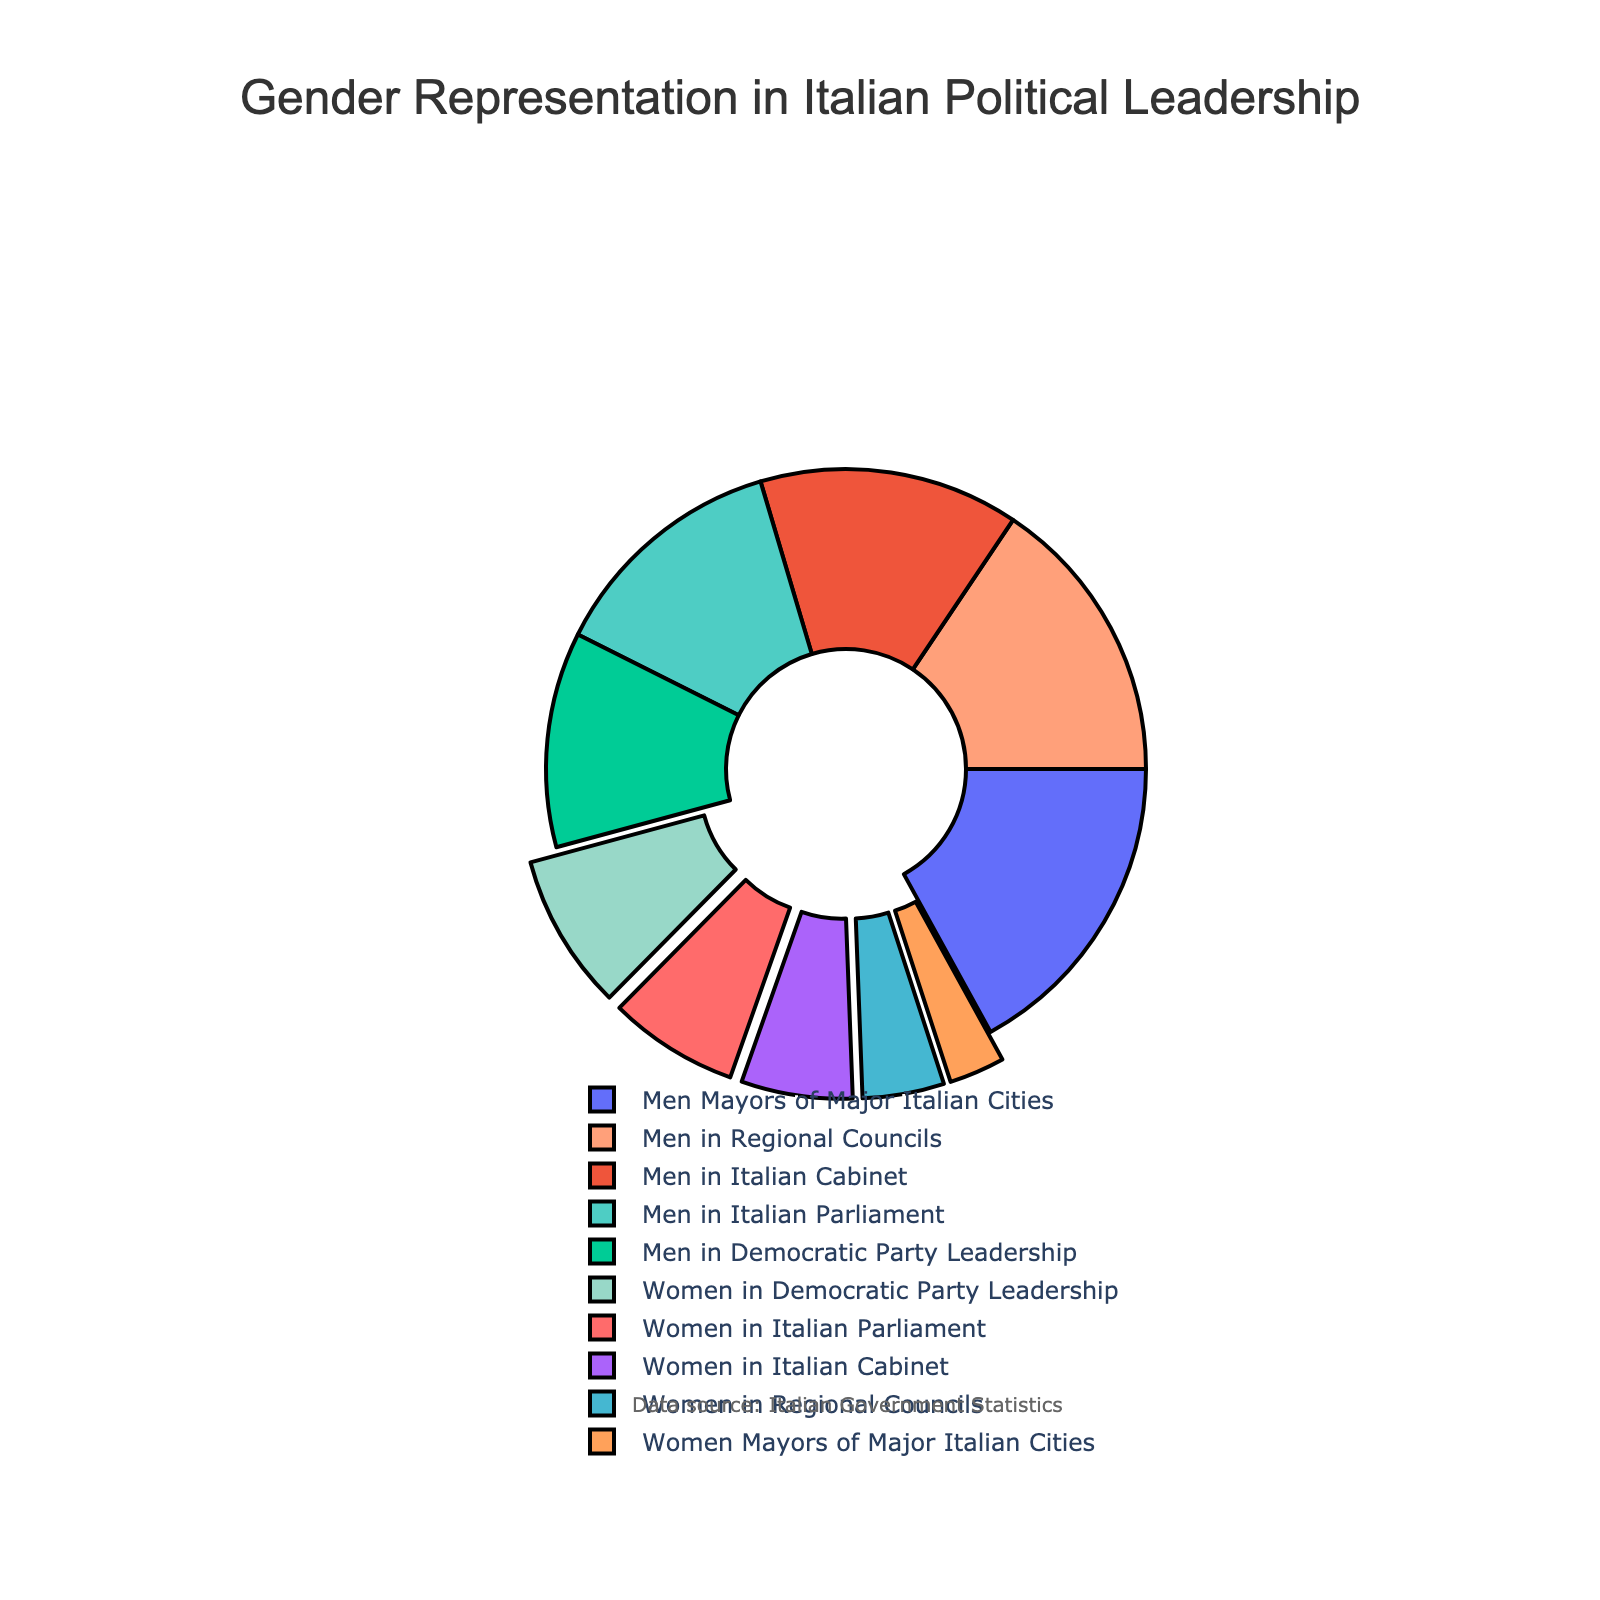How many more men than women are there in the Italian Parliament? The men account for 65% of the Italian Parliament, whereas women account for 35%. The difference in percentages is 65 - 35 = 30%.
Answer: 30% What percentage of women are in the Democratic Party leadership compared to men? Women in the Democratic Party leadership make up 42%, while men make up 58%. Therefore, women are at 42% and men at 58%.
Answer: 42% vs. 58% What is the average percentage of women in all the presented political leadership positions? The percentages of women in the five categories are 35%, 22%, 42%, 15%, and 30%. Sum these percentages: 35 + 22 + 42 + 15 + 30 = 144. Now, divide by the number of categories, which is 5. The average is 144 / 5 = 28.8%.
Answer: 28.8% Which political position has the highest gender imbalance? The position with the highest gender imbalance is assessed by the greatest difference in percentage between men and women. The Women Mayors of Major Italian Cities show the greatest difference: 85% men and 15% women, a difference of 70%.
Answer: Mayors of Major Italian Cities Compare the gender representation in the Italian Cabinet and the Regional Councils. Women in the Italian Cabinet constitute 30%, and men 70%. In Regional Councils, women constitute 22%, and men 78%. Comparing these two, the Italian Cabinet has a smaller gender gap (30% women and 70% men) compared to the Regional Councils (22% women and 78% men).
Answer: Italian Cabinet has more gender balance What is the sum of percentages of men in all leadership positions? Men in the parliament: 65%, Regional Councils: 78%, Democratic Party Leadership: 58%, Mayors: 85%, Cabinet: 70%. Summing these percentages: 65 + 78 + 58 + 85 + 70 = 356%.
Answer: 356% What percentage of total representation do women have in both Italian Parliament and Mayors of Major Italian Cities combined? Women in the Parliament have 35%, and women Mayors have 15%. Combined, their representation is 35 + 15 = 50%.
Answer: 50% What colors represent women in the pie chart? By examining the visual representation, the colors related to any labels that have 'Women' are '#FF6B6B' and '#45B7D1'.
Answer: Pink and Sea Green What is the difference in women's representation between the Democratic Party leadership and Regional Councils? Women in the Democratic Party leadership have 42%, compared to 22% in Regional Councils. The difference is 42 - 22 = 20%.
Answer: 20% 